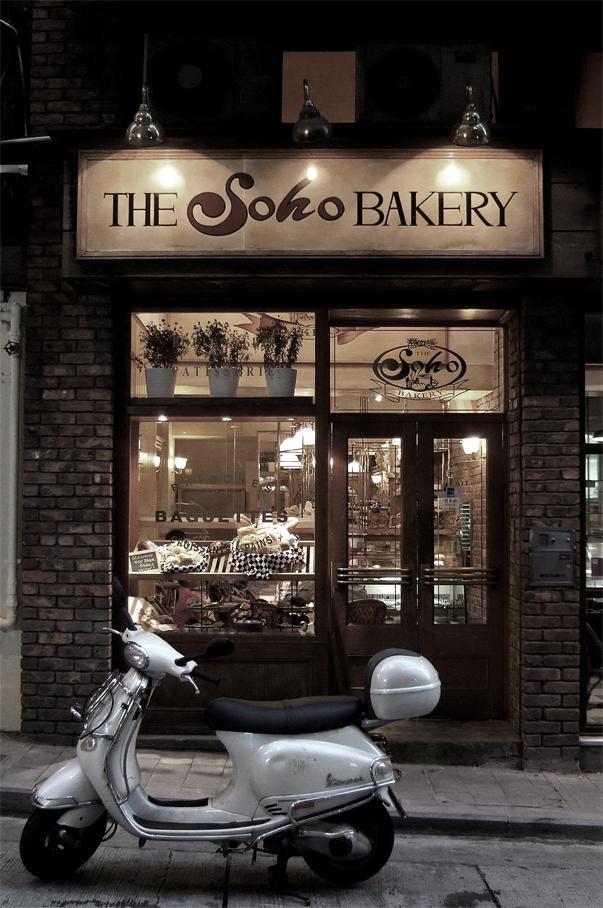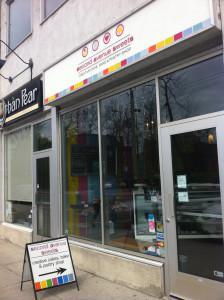The first image is the image on the left, the second image is the image on the right. Given the left and right images, does the statement "One of the store fronts has a brown awning." hold true? Answer yes or no. No. The first image is the image on the left, the second image is the image on the right. Considering the images on both sides, is "Front doors are visible in both images." valid? Answer yes or no. Yes. 